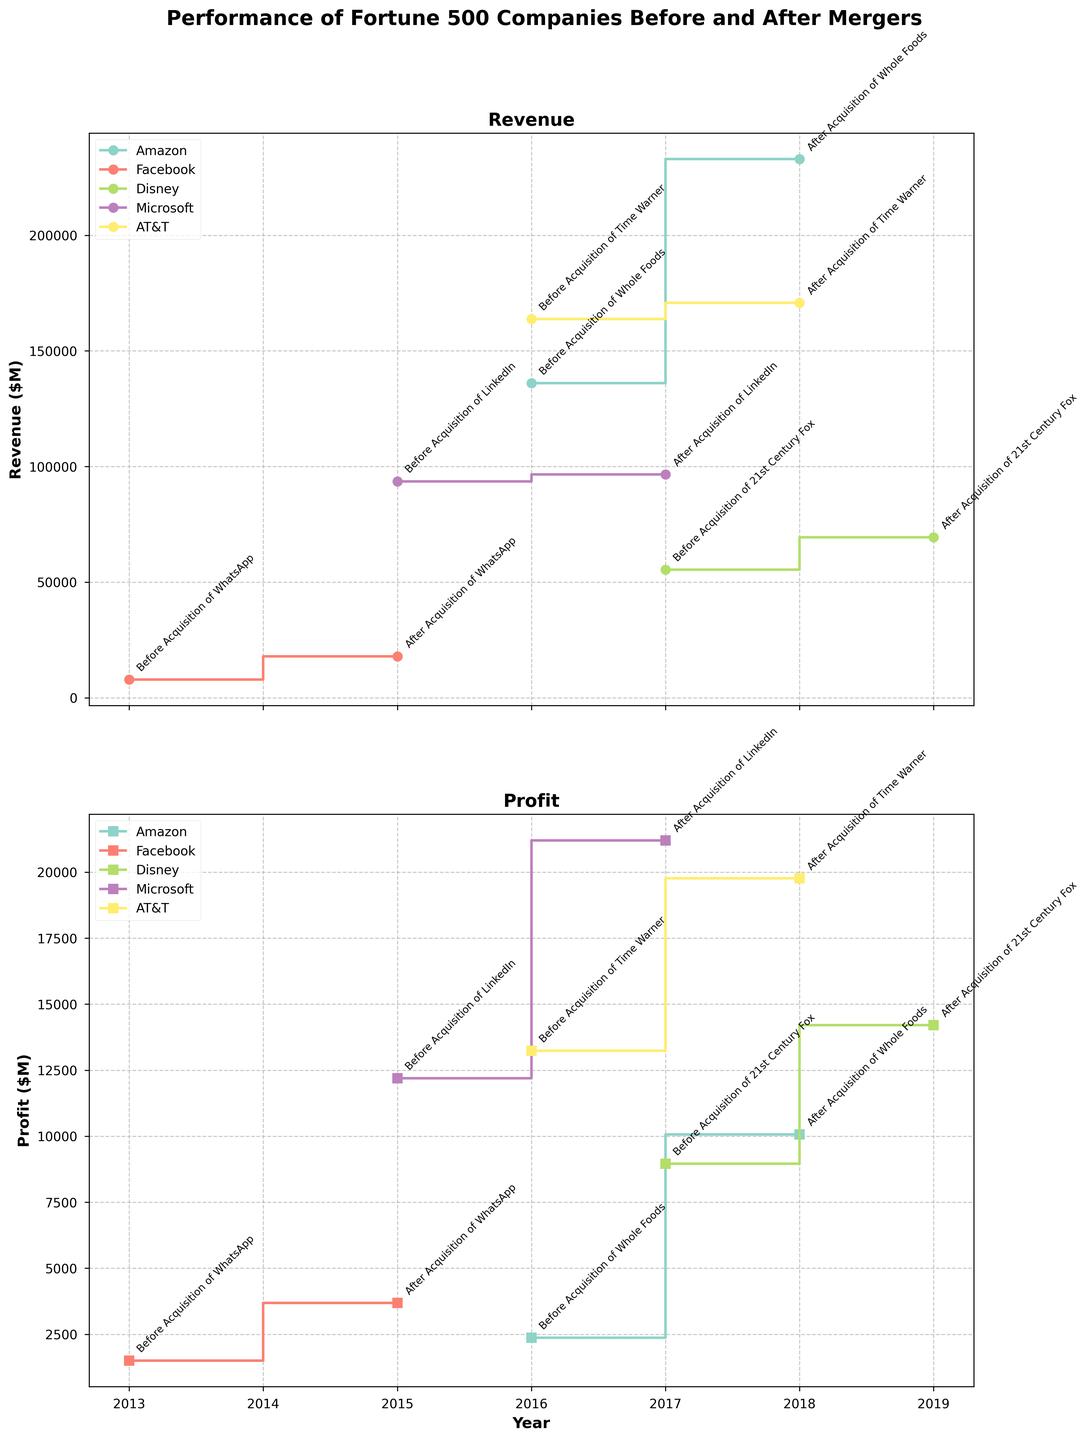What is the title of the figure? The title of the figure is stated at the top of the plot. It should be bold and easy to spot.
Answer: Performance of Fortune 500 Companies Before and After Mergers Which company had the highest revenue after their acquisition? Looking at the "Revenue" plot, find the highest value in the post-acquisition years and identify the corresponding company label.
Answer: Amazon What was Facebook's profit after acquiring WhatsApp in 2015? Refer to the "Profit" axis and locate Facebook's post-acquisition profit value marked for the year 2015.
Answer: 3688 million dollars Compare Disney's profit before and after the acquisition of 21st Century Fox. Is there an increase or decrease, and by how much? Locate Disney's profit values before and after the acquisition in the plot, then compute the difference: After = 14202, Before = 8959. Increase = 14202 - 8959.
Answer: Increase by 5243 million dollars Which company had the smallest increase in revenue after their respective acquisition? Compare the differences in revenue before and after the acquisition for each company. Microsoft had the smallest increase: After = 96571, Before = 93580, Increase = 96571 - 93580.
Answer: Microsoft How did AT&T's revenue change after acquiring Time Warner? Locate AT&T's revenue data before and after the acquisition in the plot, and determine the difference: After = 170756, Before = 163786.
Answer: Increased by 6970 million dollars What trend can be observed in Amazon's revenue before and after acquiring Whole Foods? Identify Amazon's revenue values for the specified years and compare them. The revenue increases significantly: Before = 136000, After = 232900.
Answer: Substantial increase Which company showed the largest profit after their acquisition? Identify the highest profit value in the "Profit" plot and find the corresponding company.
Answer: Microsoft How much did Facebook's revenue increase by after acquiring WhatsApp? Calculate the difference between Facebook's revenue before and after acquisition: After = 17928, Before = 7872, Increase = 17928 - 7872.
Answer: 10056 million dollars Do all companies show an increase in profit after their acquisitions? Examine the profit data for each company before and after acquisition. All companies show an increase in their profit post-acquisition.
Answer: Yes 